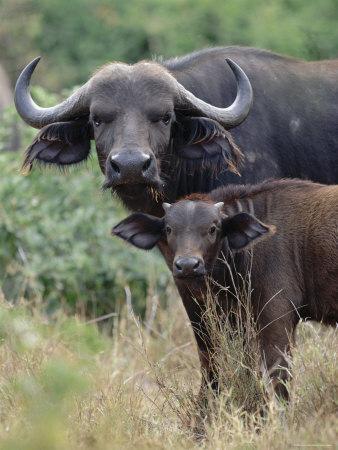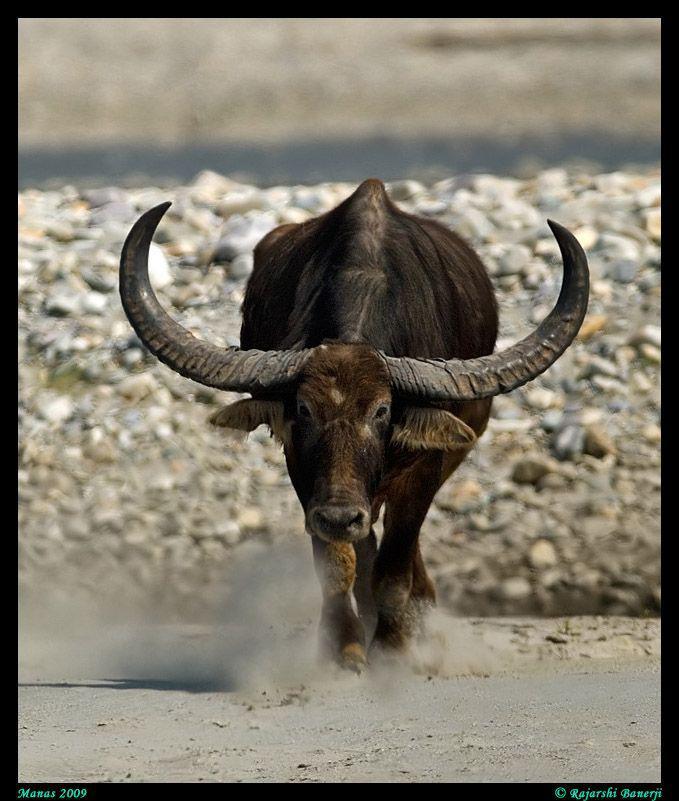The first image is the image on the left, the second image is the image on the right. Considering the images on both sides, is "There are more than three animals total." valid? Answer yes or no. No. 